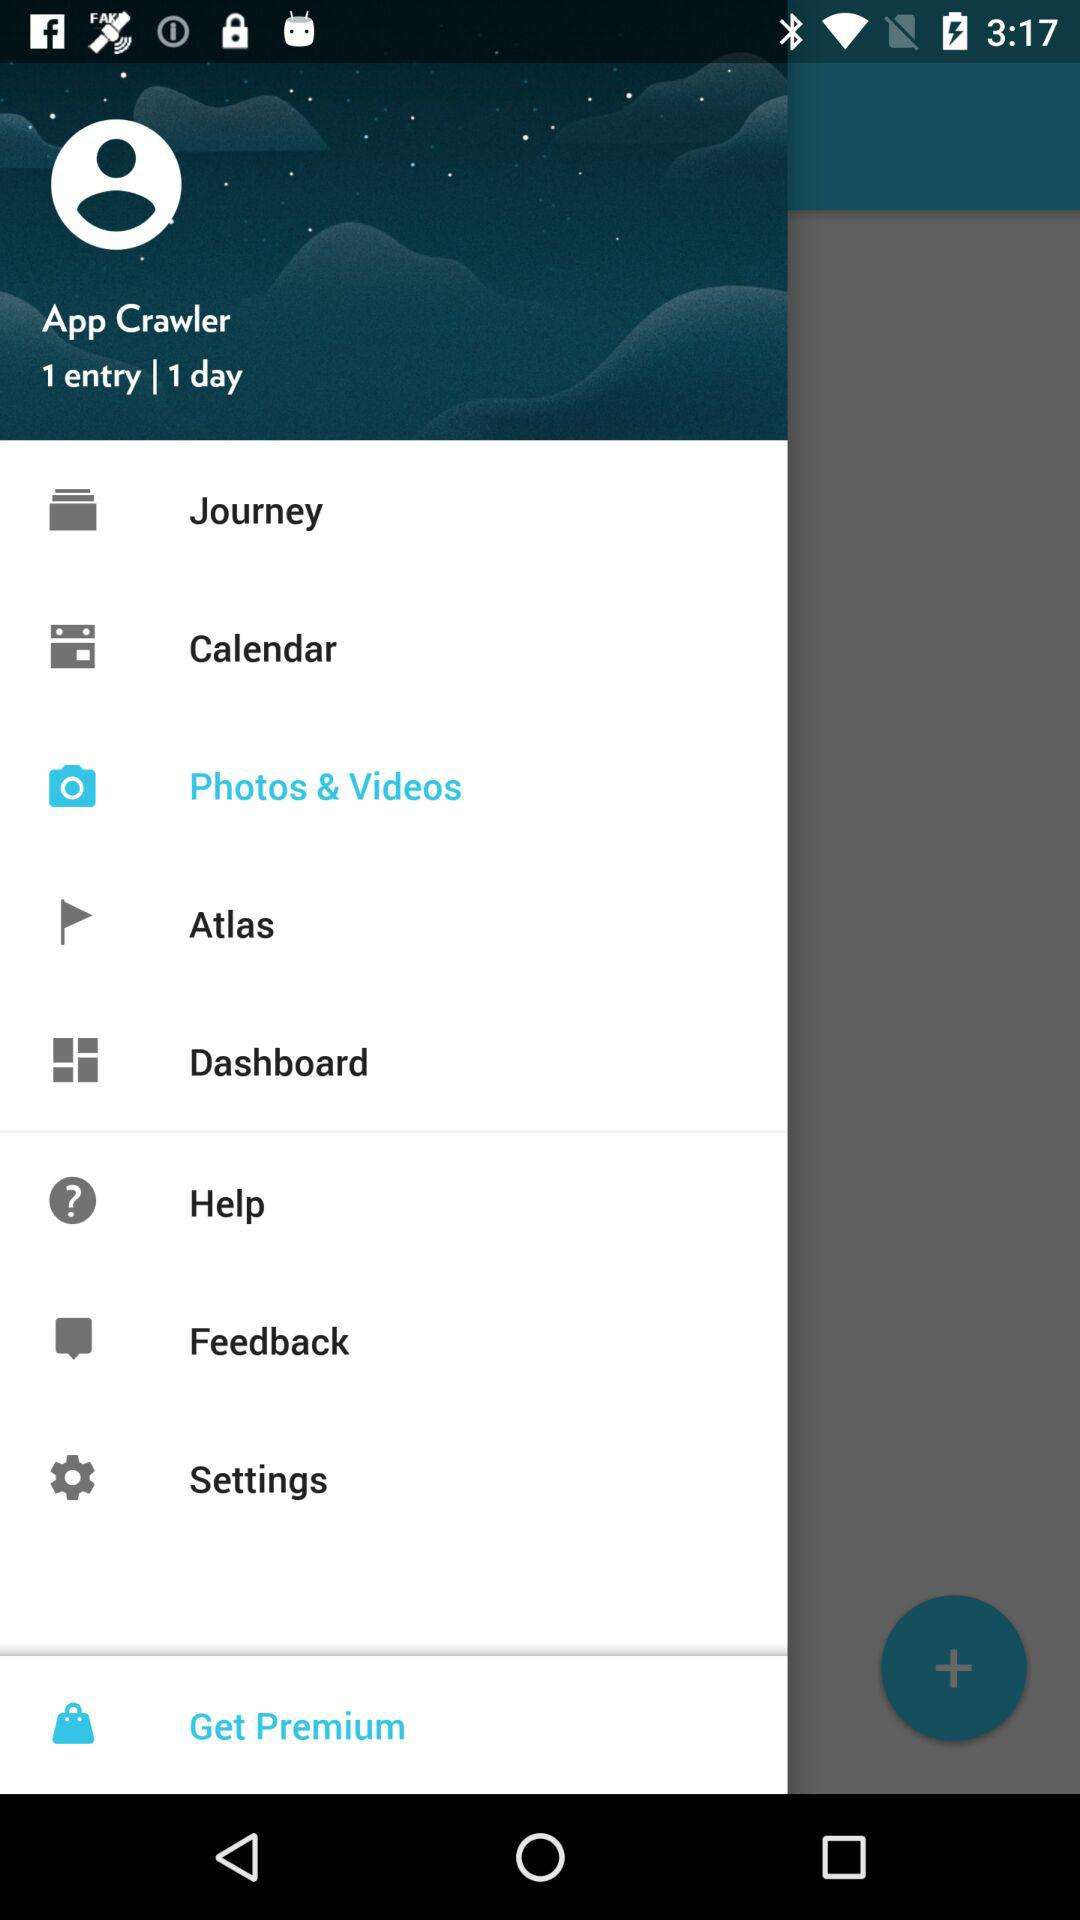What is the number of days selected? The number of days selected is 1. 